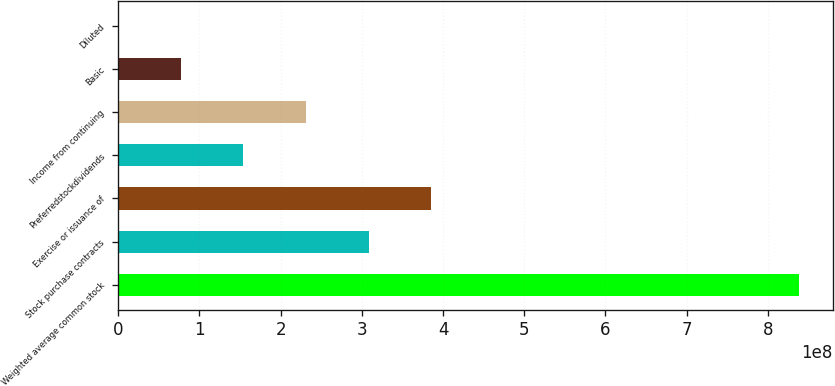<chart> <loc_0><loc_0><loc_500><loc_500><bar_chart><fcel>Weighted average common stock<fcel>Stock purchase contracts<fcel>Exercise or issuance of<fcel>Preferredstockdividends<fcel>Income from continuing<fcel>Basic<fcel>Diluted<nl><fcel>8.38175e+08<fcel>3.08282e+08<fcel>3.85352e+08<fcel>1.54141e+08<fcel>2.31211e+08<fcel>7.70704e+07<fcel>3.6<nl></chart> 